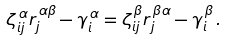<formula> <loc_0><loc_0><loc_500><loc_500>\zeta ^ { \, \alpha } _ { i j } r ^ { \, \alpha \beta } _ { j } - \gamma ^ { \, \alpha } _ { i } = \zeta ^ { \, \beta } _ { i j } r ^ { \, \beta \alpha } _ { j } - \gamma ^ { \, \beta } _ { i } \, .</formula> 